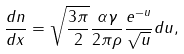Convert formula to latex. <formula><loc_0><loc_0><loc_500><loc_500>\frac { d n } { d x } = \sqrt { \frac { 3 \pi } { 2 } } \frac { \alpha \gamma } { 2 \pi \rho } \frac { e ^ { - u } } { \sqrt { u } } d u ,</formula> 